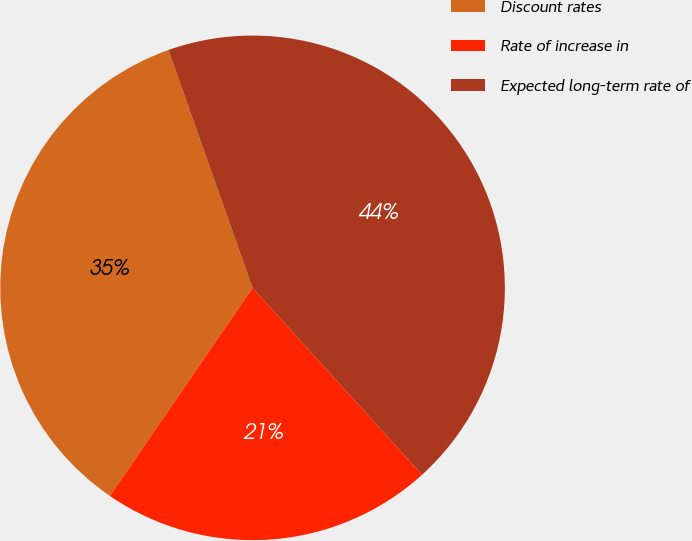<chart> <loc_0><loc_0><loc_500><loc_500><pie_chart><fcel>Discount rates<fcel>Rate of increase in<fcel>Expected long-term rate of<nl><fcel>35.02%<fcel>21.29%<fcel>43.69%<nl></chart> 